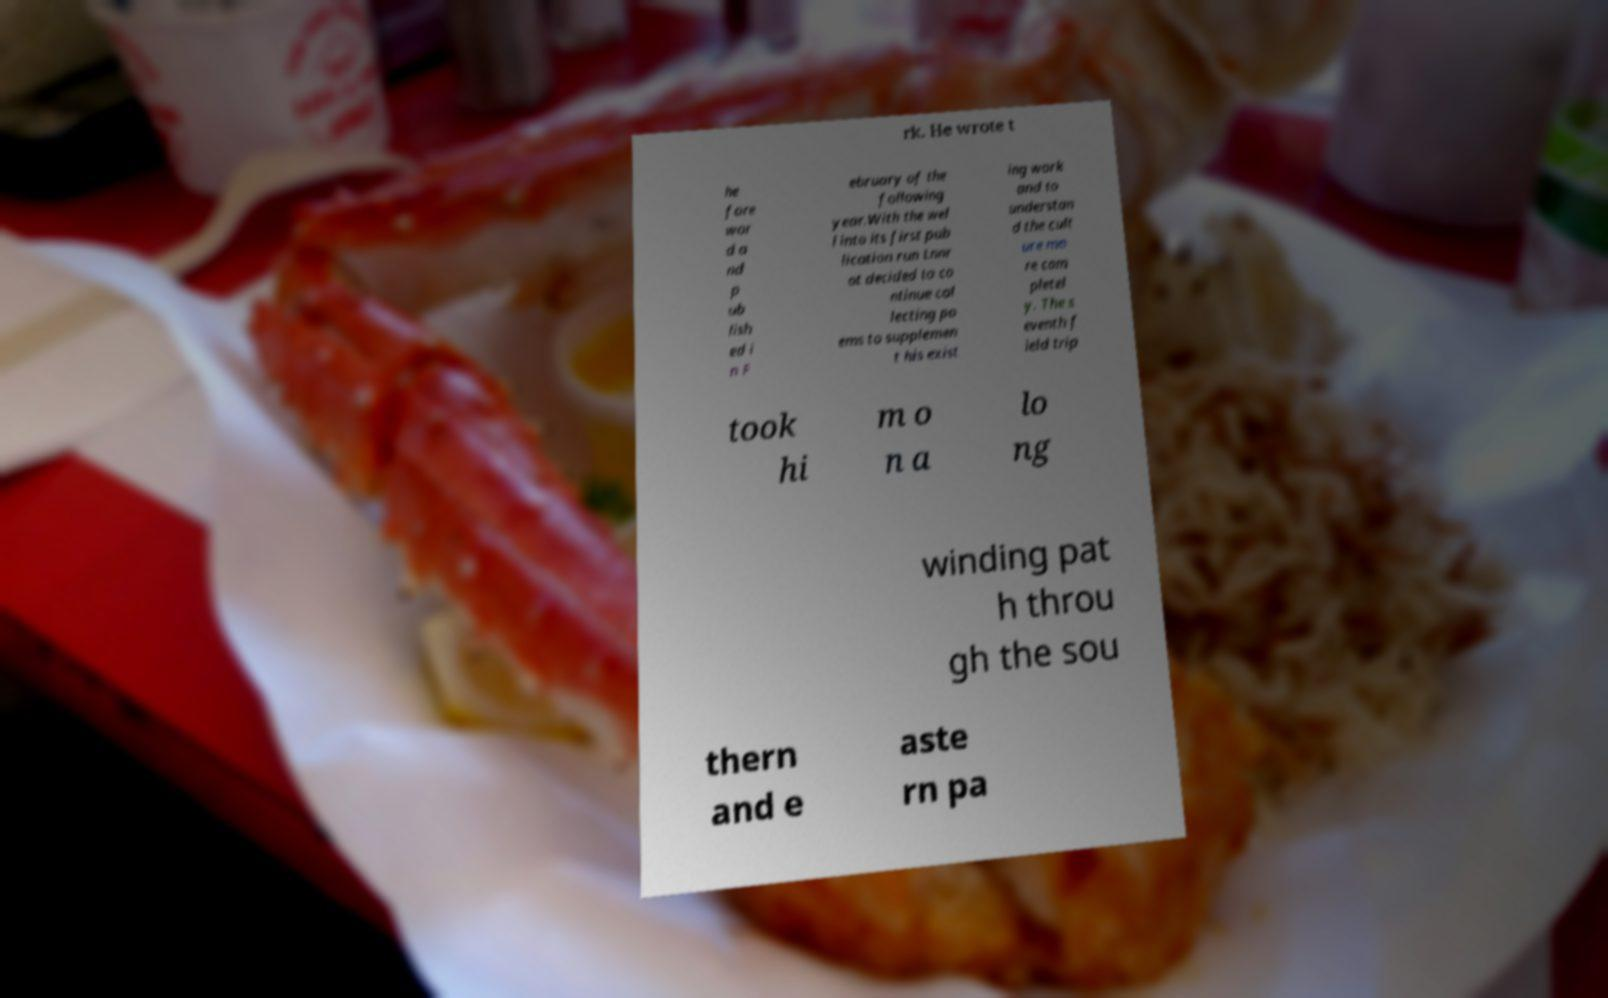Could you assist in decoding the text presented in this image and type it out clearly? rk. He wrote t he fore wor d a nd p ub lish ed i n F ebruary of the following year.With the wel l into its first pub lication run Lnnr ot decided to co ntinue col lecting po ems to supplemen t his exist ing work and to understan d the cult ure mo re com pletel y. The s eventh f ield trip took hi m o n a lo ng winding pat h throu gh the sou thern and e aste rn pa 